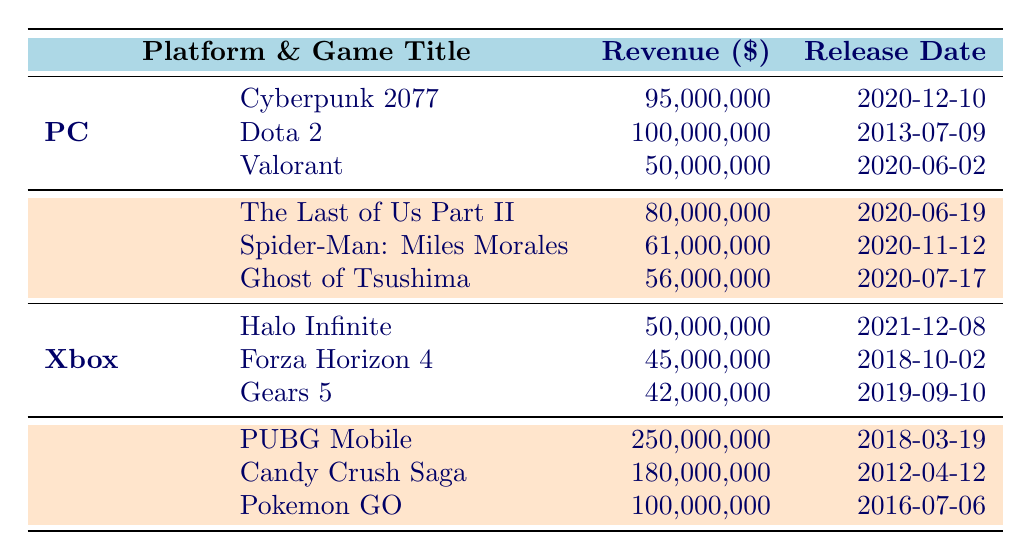What is the revenue for Dota 2? The row for Dota 2 under the PC platform shows the revenue listed as 100,000,000.
Answer: 100,000,000 Which game has the highest revenue on Mobile? In the Mobile section, PUBG Mobile shows the highest revenue, listed at 250,000,000.
Answer: PUBG Mobile What is the total revenue generated by games on the PlayStation platform? Adding the revenues: The Last of Us Part II (80,000,000) + Spider-Man: Miles Morales (61,000,000) + Ghost of Tsushima (56,000,000) gives a total of 197,000,000.
Answer: 197,000,000 True or False: Halo Infinite has a higher revenue than Forza Horizon 4. Comparing the two, Halo Infinite has a revenue of 50,000,000, while Forza Horizon 4 has 45,000,000. Therefore, Halo Infinite does have a higher revenue.
Answer: True What game title was released first in the PC platform? Looking at the release dates, Dota 2 was released on 2013-07-09, while the others, Cyberpunk 2077 (2020-12-10) and Valorant (2020-06-02) were released later, making Dota 2 the earliest.
Answer: Dota 2 What is the average revenue of mobile games listed? The revenues for Mobile are: PUBG Mobile (250,000,000), Candy Crush Saga (180,000,000), and Pokemon GO (100,000,000). Total = 530,000,000. The average is 530,000,000 / 3 = 176,666,667.
Answer: 176,666,667 True or False: Valorant has a revenue equal to 50,000,000. Valorant's revenue is listed as 50,000,000, confirming that this statement is true.
Answer: True Which platform has the lowest total revenue when combining all its titles? Total revenues of each platform: PC (100,000,000 + 95,000,000 + 50,000,000 = 245,000,000), PlayStation (80,000,000 + 61,000,000 + 56,000,000 = 197,000,000), Xbox (50,000,000 + 45,000,000 + 42,000,000 = 137,000,000), Mobile (250,000,000 + 180,000,000 + 100,000,000 = 530,000,000). Xbox with 137,000,000 is the lowest.
Answer: Xbox How much more revenue did Candy Crush Saga earn compared to Gears 5? Candy Crush Saga earned 180,000,000, while Gears 5 earned 42,000,000. So, the difference is 180,000,000 - 42,000,000 = 138,000,000.
Answer: 138,000,000 